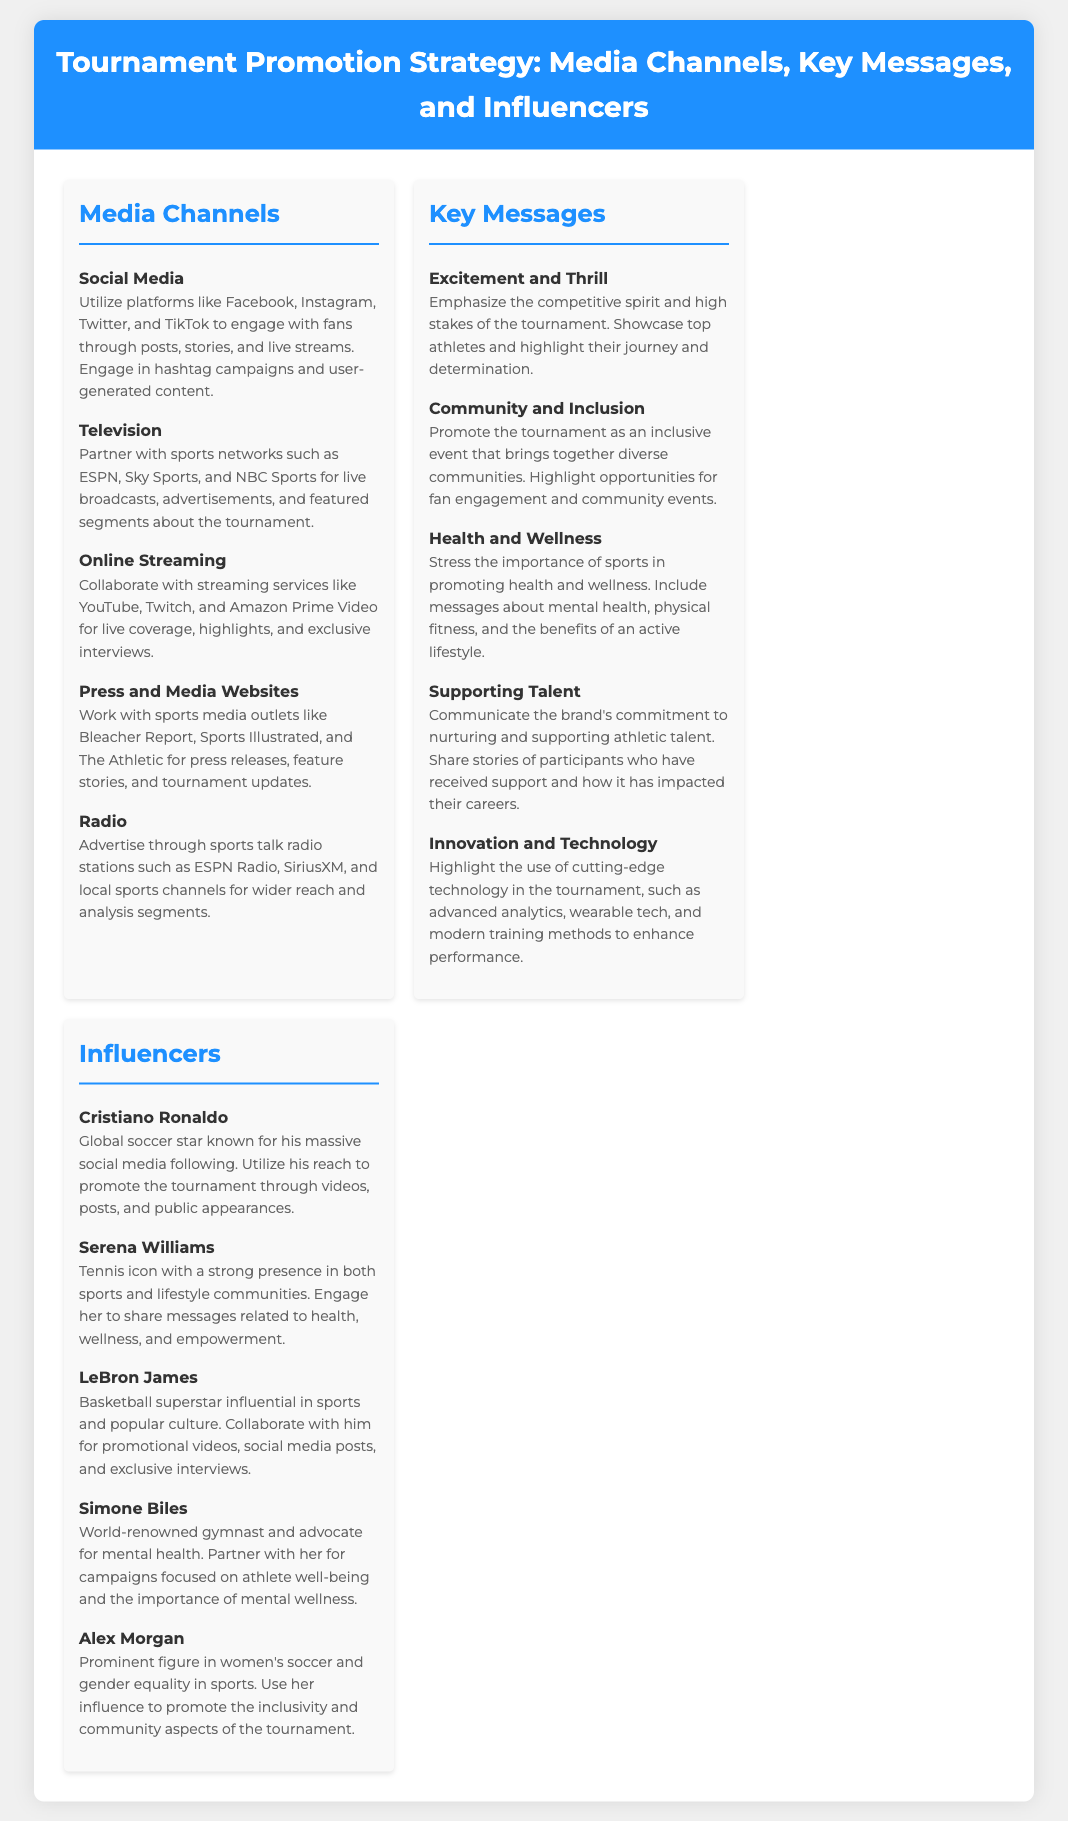what media channel involves user-generated content? User-generated content is specifically mentioned in the section for Social Media, which encourages engagement through posts, stories, and hashtag campaigns.
Answer: Social Media which sports network is mentioned for television advertisements? The television advertisements mentioned include partnerships with ESPN, a well-known sports network, to enhance tournament visibility.
Answer: ESPN who is a tennis icon involved in promoting health and wellness? The document lists Serena Williams as a tennis icon who can engage audiences on messages related to health, wellness, and empowerment.
Answer: Serena Williams what key message emphasizes community engagement? The message that promotes community and inclusion highlights the tournament's role in bringing diverse communities together and engaging fans.
Answer: Community and Inclusion how many influencers are listed in the document? The document states a total of five influencers that are listed under the Influencers section of the fact sheet.
Answer: Five which media channel is related to live coverage and exclusive interviews? Online Streaming is the media channel specifically associated with live coverage, highlights, and exclusive interviews for the tournament.
Answer: Online Streaming which key message highlights the use of advanced technologies? The key message of Innovation and Technology discusses the incorporation of cutting-edge technologies in the tournament, enhancing performance.
Answer: Innovation and Technology who is known for advocating mental health? Simone Biles is highlighted as a world-renowned gymnast who advocates for mental health issues.
Answer: Simone Biles what platform is mentioned for sports talk radio advertising? ESPN Radio is explicitly mentioned as a platform for advertising through sports talk radio channels for wider reach.
Answer: ESPN Radio 